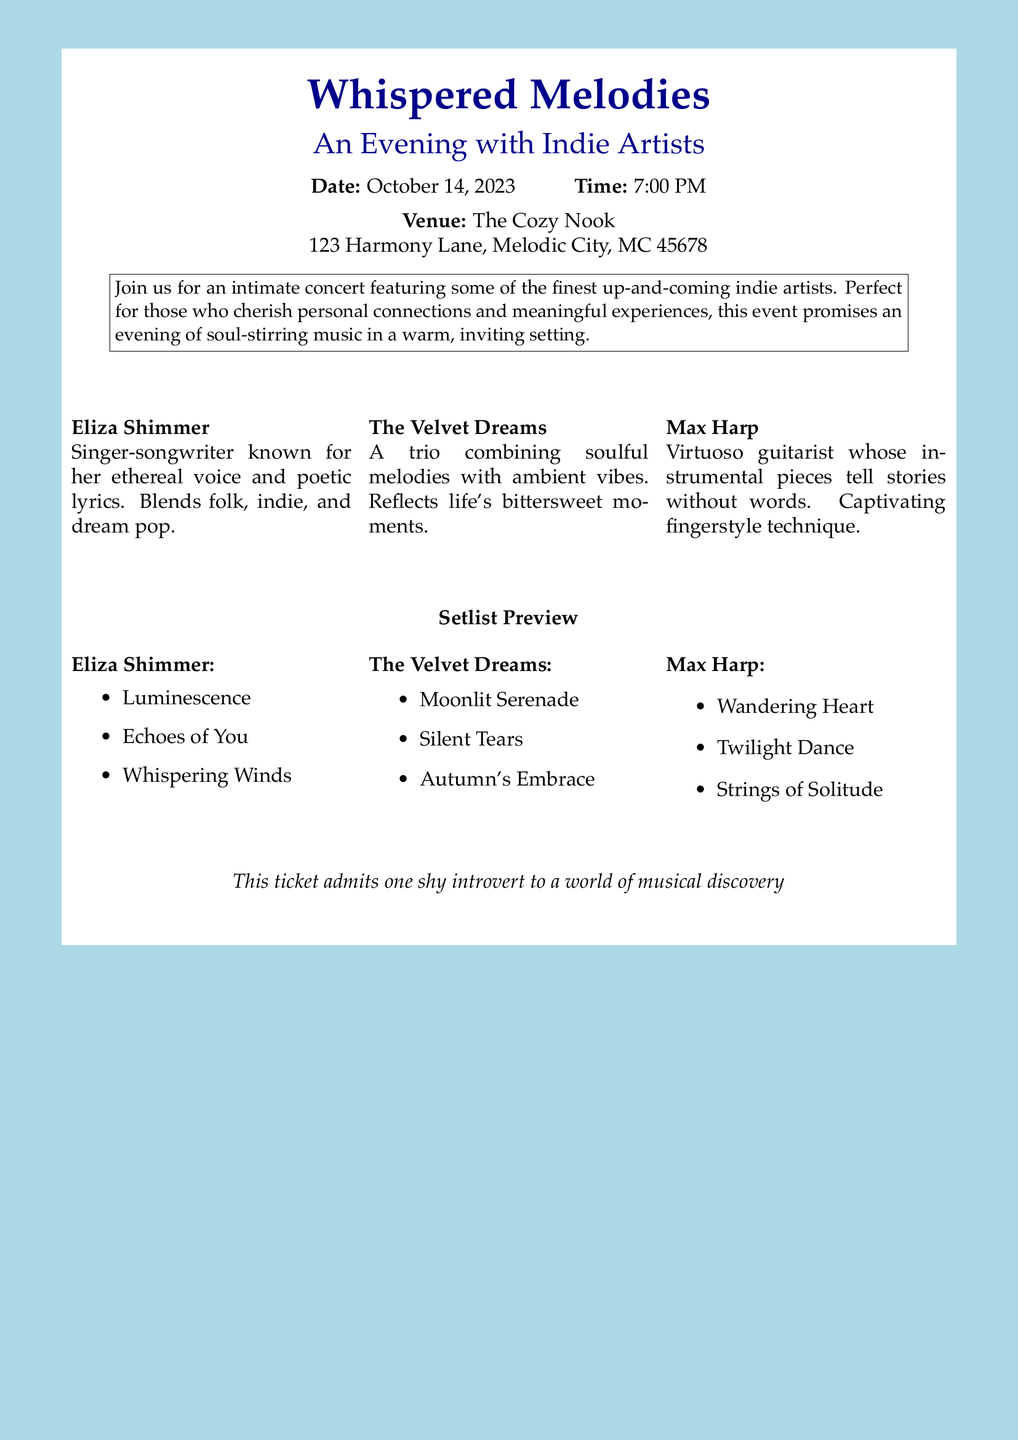What is the event title? The event title is prominently displayed at the top of the document.
Answer: Whispered Melodies What is the date of the concert? The date is mentioned clearly in the details section of the document.
Answer: October 14, 2023 What time does the concert start? The start time is listed right next to the date in the document.
Answer: 7:00 PM Where is the concert being held? The venue information is provided in a dedicated section of the document.
Answer: The Cozy Nook Who is the first artist listed? The first artist is highlighted in the multi-column section of the document.
Answer: Eliza Shimmer What genre does Eliza Shimmer blend? The genres associated with Eliza Shimmer are described in her profile section.
Answer: Folk, indie, and dream pop Which song is Max Harp going to play? The setlist preview includes specific songs for each artist.
Answer: Wandering Heart How many artists are featured in the concert? The document outlines the number of artists in the multi-column section.
Answer: Three What type of experience does the concert promise? The description in the white box indicates the nature of the concert experience.
Answer: Intimate concert 